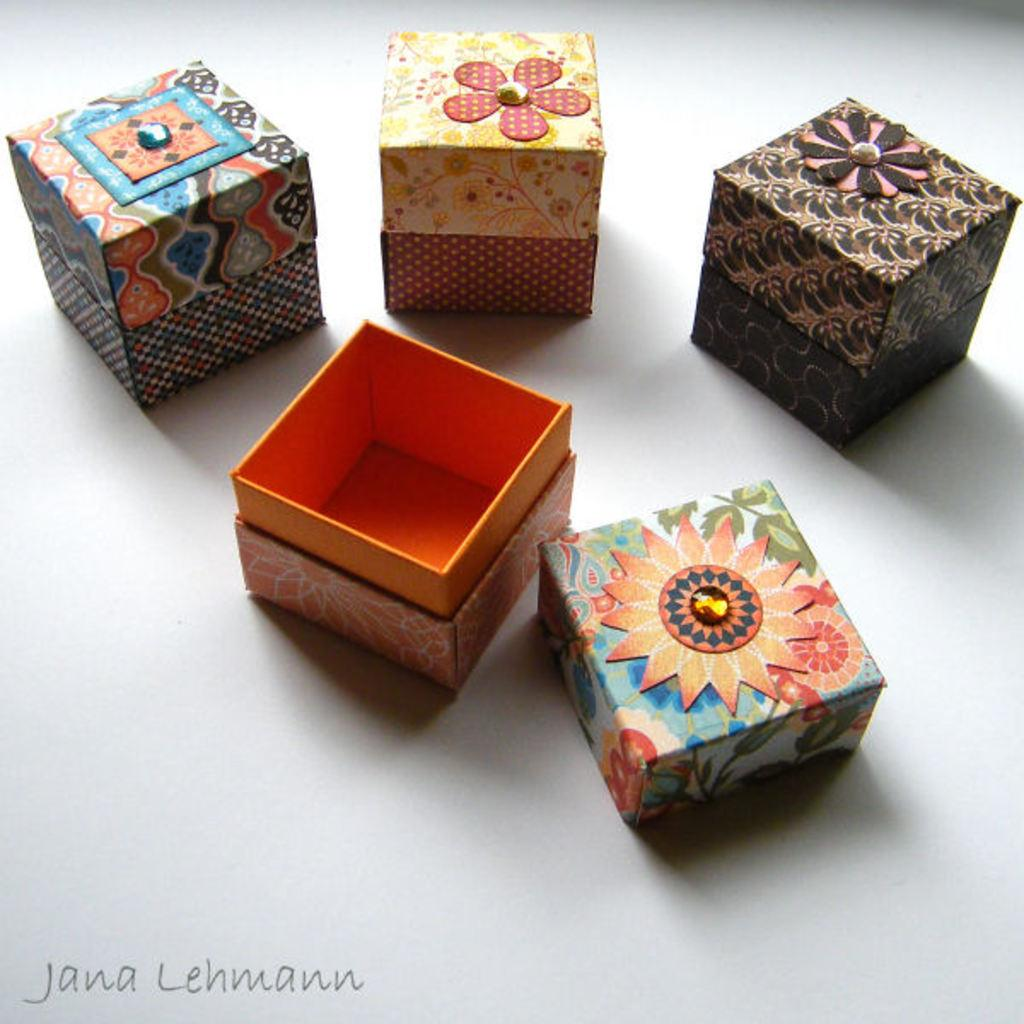<image>
Share a concise interpretation of the image provided. four decorated gift boxes copy right by Jana Lehmann 